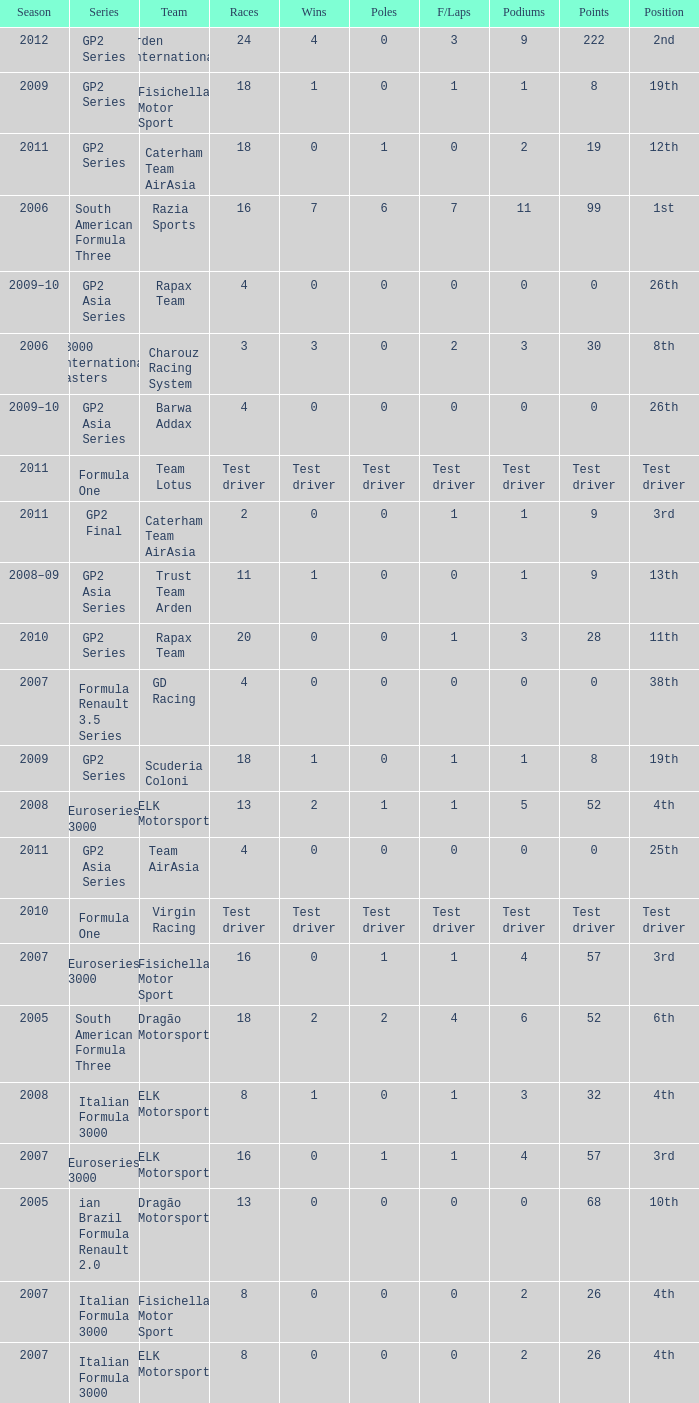In which season did he have 0 Poles and 19th position in the GP2 Series? 2009, 2009. 